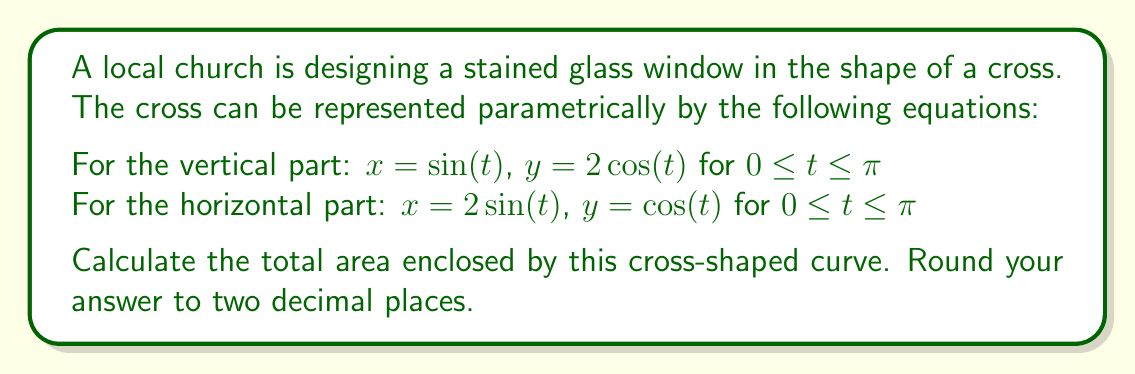Can you solve this math problem? To calculate the area enclosed by this parametric curve, we'll use Green's Theorem, which states that for a closed curve C, the area A is given by:

$$A = \frac{1}{2} \oint_C (xdy - ydx)$$

We'll calculate this for each part of the cross separately and then add them together.

1. For the vertical part:
   $x = \sin(t)$, $y = 2\cos(t)$, $0 \leq t \leq \pi$
   $dx = \cos(t)dt$, $dy = -2\sin(t)dt$
   
   $$A_1 = \frac{1}{2} \int_0^\pi (\sin(t)(-2\sin(t)) - 2\cos(t)\cos(t))dt$$
   $$= -\int_0^\pi (\sin^2(t) + \cos^2(t))dt = -\int_0^\pi dt = -\pi$$

2. For the horizontal part:
   $x = 2\sin(t)$, $y = \cos(t)$, $0 \leq t \leq \pi$
   $dx = 2\cos(t)dt$, $dy = -\sin(t)dt$
   
   $$A_2 = \frac{1}{2} \int_0^\pi (2\sin(t)(-\sin(t)) - \cos(t)(2\cos(t)))dt$$
   $$= -\int_0^\pi (\sin^2(t) + \cos^2(t))dt = -\int_0^\pi dt = -\pi$$

The total area is the sum of the absolute values of $A_1$ and $A_2$:

$$A_{total} = |A_1| + |A_2| = \pi + \pi = 2\pi$$

Converting to a decimal and rounding to two places:
$$2\pi \approx 6.28$$
Answer: 6.28 square units 